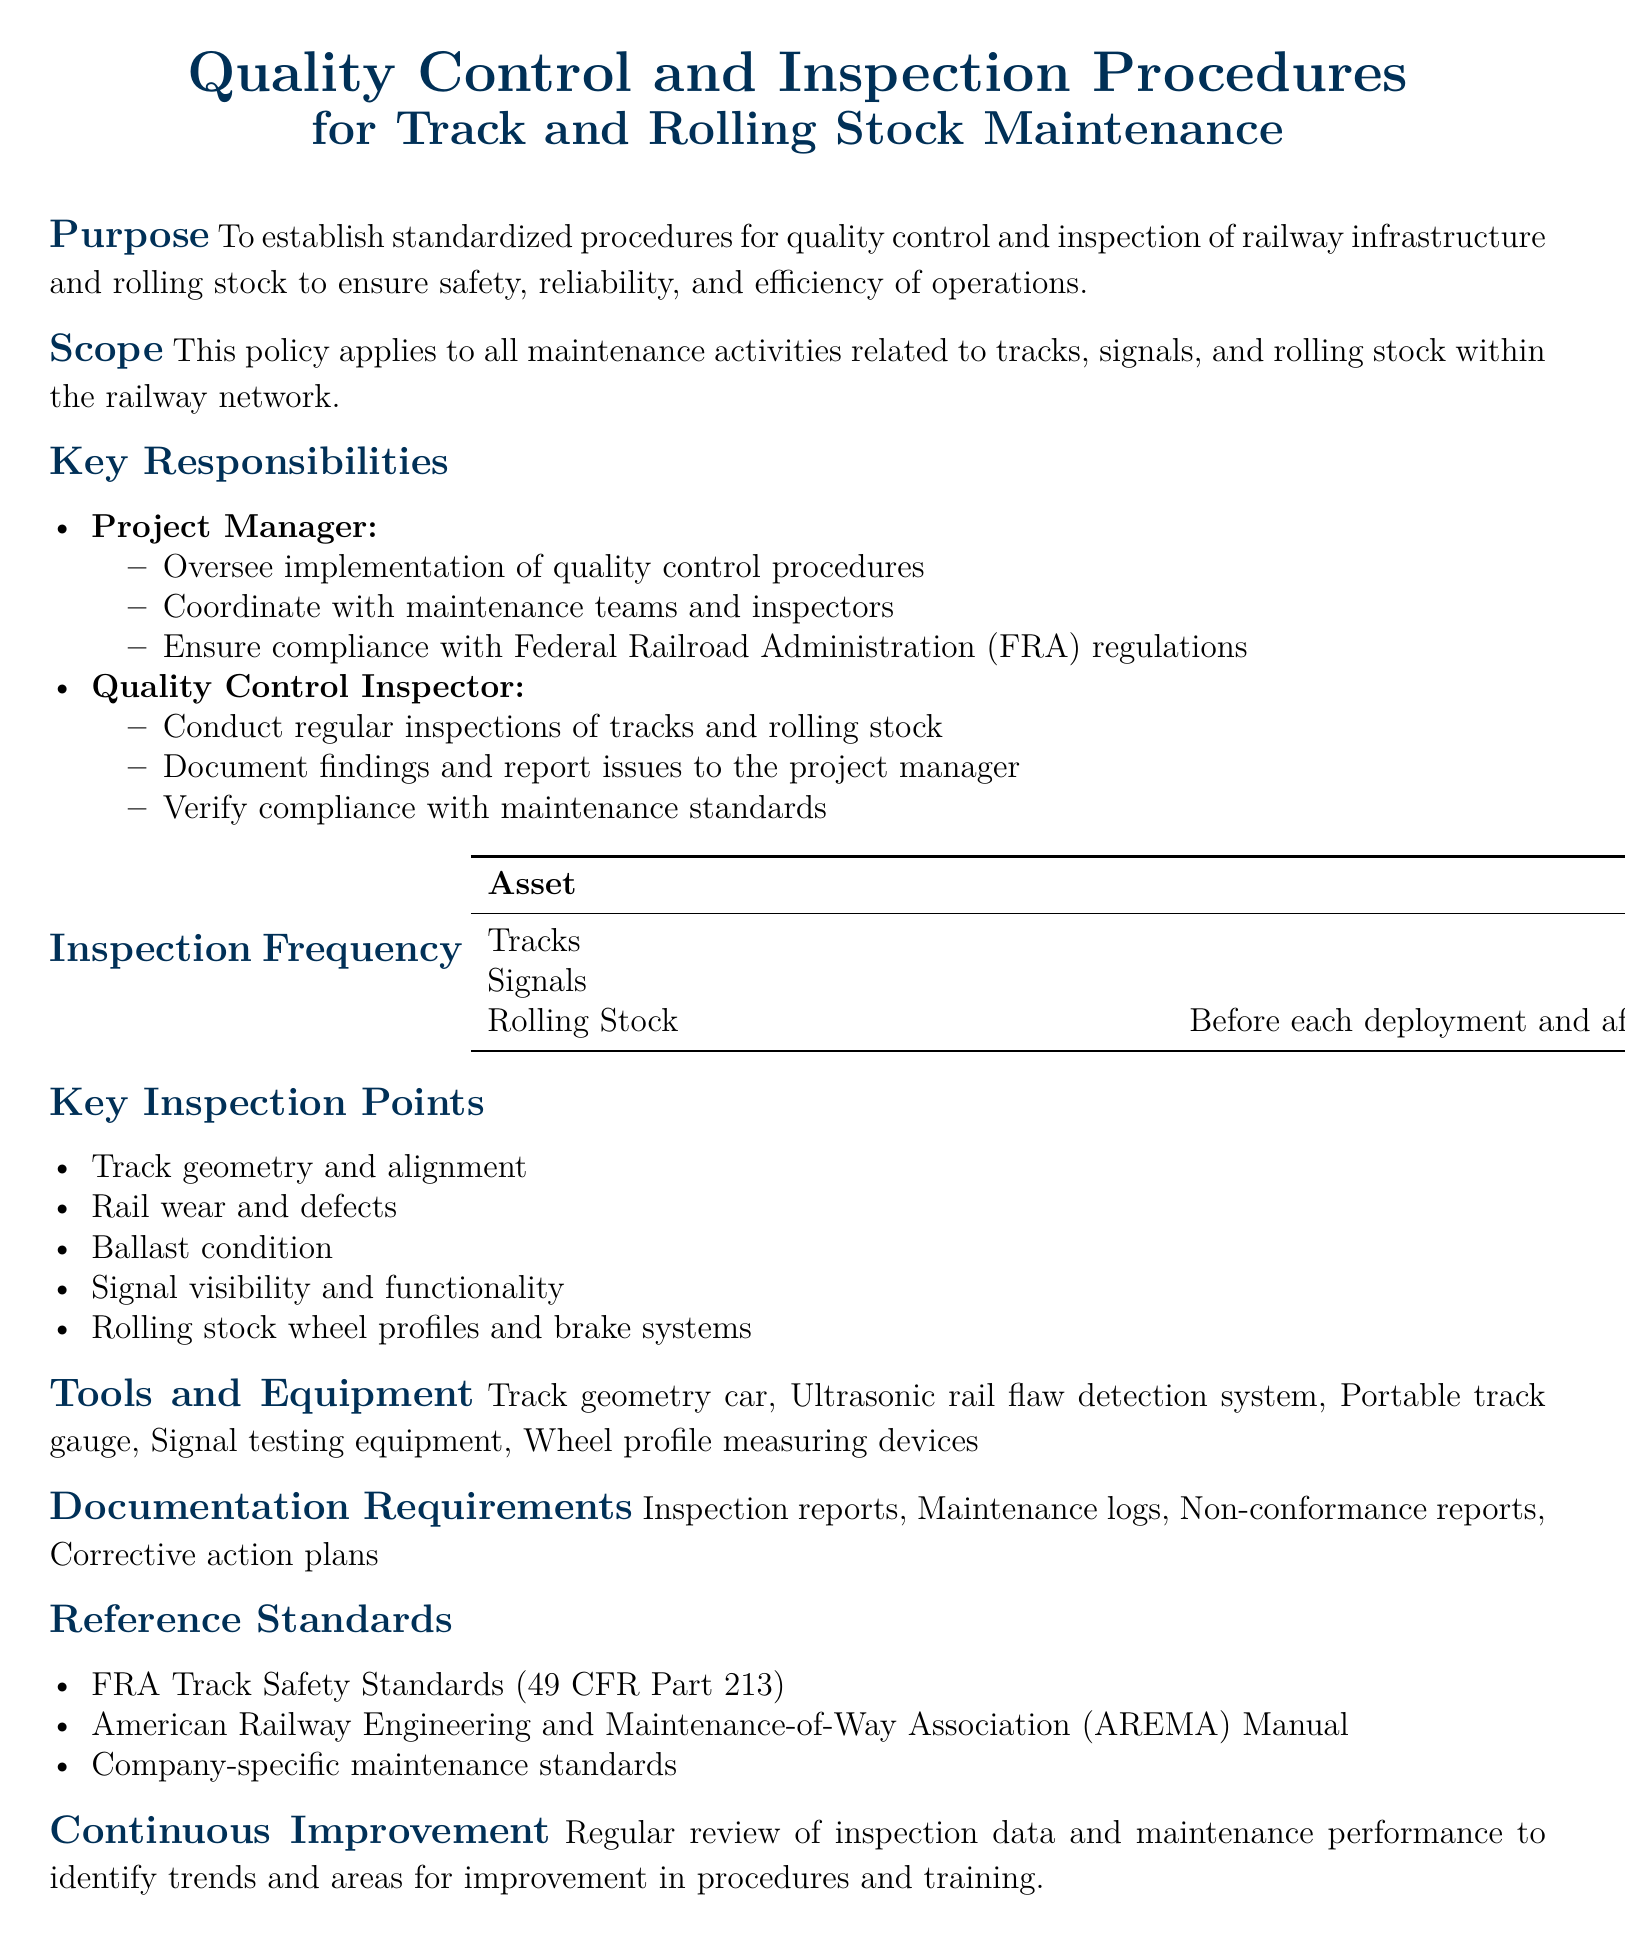What is the purpose of the policy? The purpose of the policy is to establish standardized procedures for quality control and inspection of railway infrastructure and rolling stock to ensure safety, reliability, and efficiency of operations.
Answer: Establish standardized procedures for quality control and inspection What is the inspection frequency for tracks? The document specifies the frequency of inspections for different assets, with tracks specifically being inspected weekly.
Answer: Weekly Who is responsible for conducting regular inspections? The responsibilities outlined in the document indicate that the quality control inspector is tasked with conducting regular inspections.
Answer: Quality Control Inspector What are the key inspection points listed in the document? The document provides a list of key inspection points including track geometry and alignment, rail wear and defects, and more.
Answer: Track geometry and alignment, rail wear and defects, ballast condition, signal visibility and functionality, rolling stock wheel profiles and brake systems What is the documentation requirement mentioned? The document states that inspection reports, maintenance logs, non-conformance reports, and corrective action plans are required for documentation.
Answer: Inspection reports, Maintenance logs, Non-conformance reports, Corrective action plans How often are signals inspected? The frequency of signal inspections, as outlined in the document, is monthly.
Answer: Monthly What manual is referenced for railway engineering standards? The document references the American Railway Engineering and Maintenance-of-Way Association Manual as a standard.
Answer: AREMA Manual What type of improvement does the document emphasize? The document emphasizes conducting a regular review of inspection data and maintenance performance for continuous improvement.
Answer: Continuous Improvement 